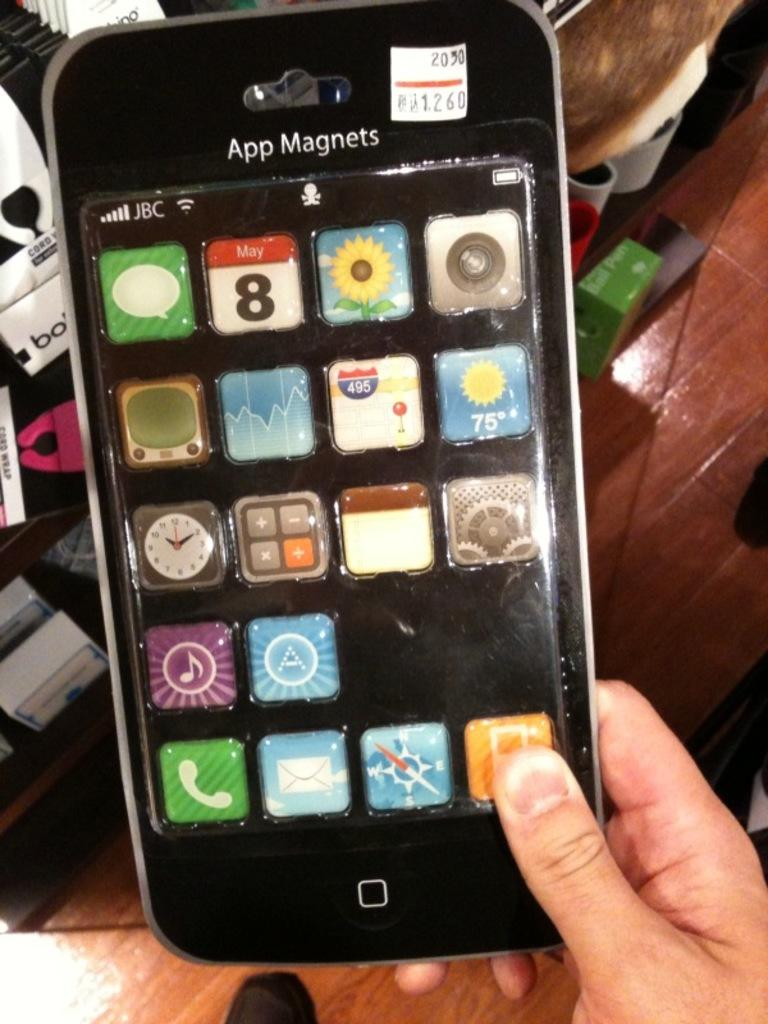<image>
Present a compact description of the photo's key features. A person is holding a package that is shaped like an iPhone and says App Magnets. 